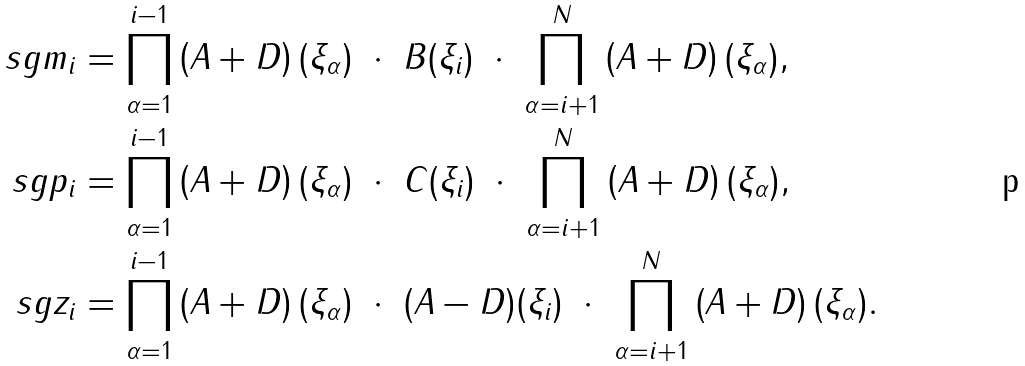Convert formula to latex. <formula><loc_0><loc_0><loc_500><loc_500>\ s g m _ { i } & = \prod _ { \alpha = 1 } ^ { i - 1 } \left ( A + D \right ) ( \xi _ { \alpha } ) \ \cdot \ B ( \xi _ { i } ) \ \cdot \ \prod _ { \alpha = i + 1 } ^ { N } \left ( A + D \right ) ( \xi _ { \alpha } ) , \\ \ s g p _ { i } & = \prod _ { \alpha = 1 } ^ { i - 1 } \left ( A + D \right ) ( \xi _ { \alpha } ) \ \cdot \ C ( \xi _ { i } ) \ \cdot \ \prod _ { \alpha = i + 1 } ^ { N } \left ( A + D \right ) ( \xi _ { \alpha } ) , \\ \ s g z _ { i } & = \prod _ { \alpha = 1 } ^ { i - 1 } \left ( A + D \right ) ( \xi _ { \alpha } ) \ \cdot \ ( A - D ) ( \xi _ { i } ) \ \cdot \ \prod _ { \alpha = i + 1 } ^ { N } \left ( A + D \right ) ( \xi _ { \alpha } ) .</formula> 